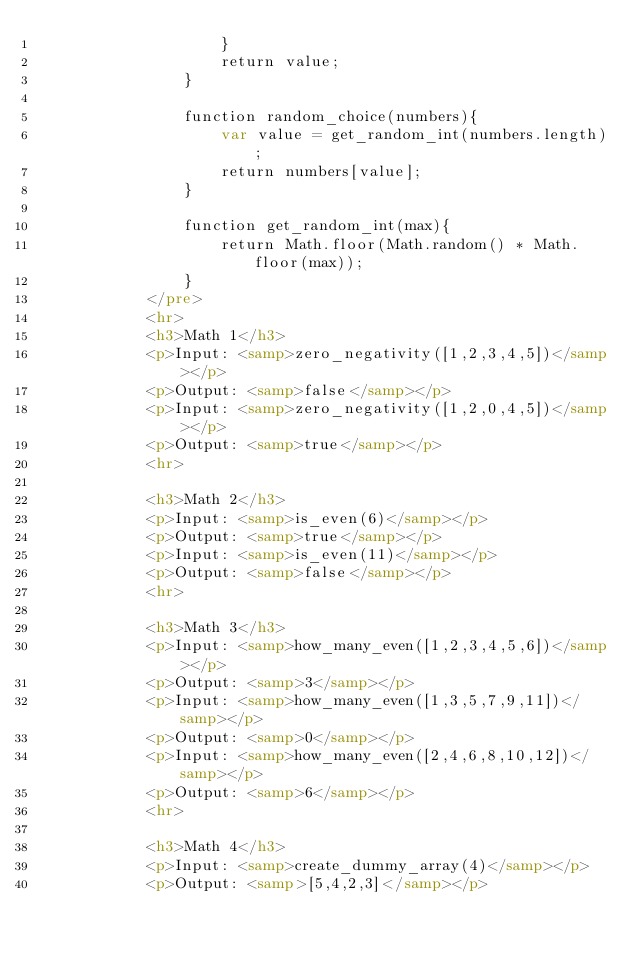<code> <loc_0><loc_0><loc_500><loc_500><_HTML_>                    }
                    return value;
                }
        
                function random_choice(numbers){
                    var value = get_random_int(numbers.length);
                    return numbers[value];
                }
    
                function get_random_int(max){
                    return Math.floor(Math.random() * Math.floor(max));
                }
            </pre>
            <hr>
            <h3>Math 1</h3>
            <p>Input: <samp>zero_negativity([1,2,3,4,5])</samp></p>
            <p>Output: <samp>false</samp></p>
            <p>Input: <samp>zero_negativity([1,2,0,4,5])</samp></p>
            <p>Output: <samp>true</samp></p>
            <hr>

            <h3>Math 2</h3>
            <p>Input: <samp>is_even(6)</samp></p>
            <p>Output: <samp>true</samp></p>
            <p>Input: <samp>is_even(11)</samp></p>
            <p>Output: <samp>false</samp></p>
            <hr>

            <h3>Math 3</h3>
            <p>Input: <samp>how_many_even([1,2,3,4,5,6])</samp></p>
            <p>Output: <samp>3</samp></p>
            <p>Input: <samp>how_many_even([1,3,5,7,9,11])</samp></p>
            <p>Output: <samp>0</samp></p>
            <p>Input: <samp>how_many_even([2,4,6,8,10,12])</samp></p>
            <p>Output: <samp>6</samp></p>
            <hr>

            <h3>Math 4</h3>
            <p>Input: <samp>create_dummy_array(4)</samp></p>
            <p>Output: <samp>[5,4,2,3]</samp></p></code> 